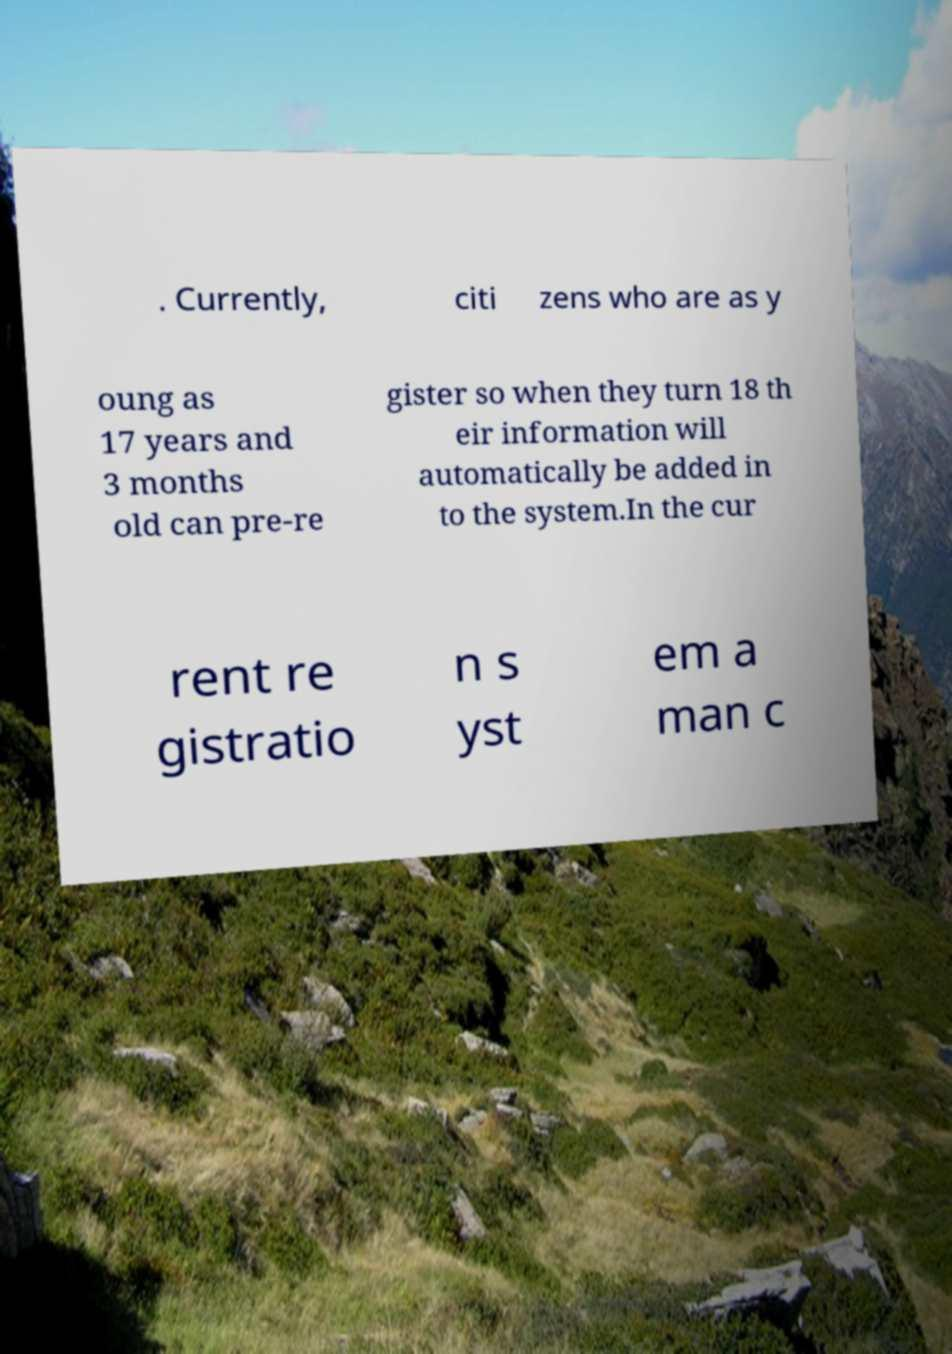What messages or text are displayed in this image? I need them in a readable, typed format. . Currently, citi zens who are as y oung as 17 years and 3 months old can pre-re gister so when they turn 18 th eir information will automatically be added in to the system.In the cur rent re gistratio n s yst em a man c 